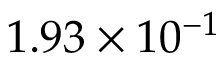Convert formula to latex. <formula><loc_0><loc_0><loc_500><loc_500>1 . 9 3 \times 1 0 ^ { - 1 }</formula> 